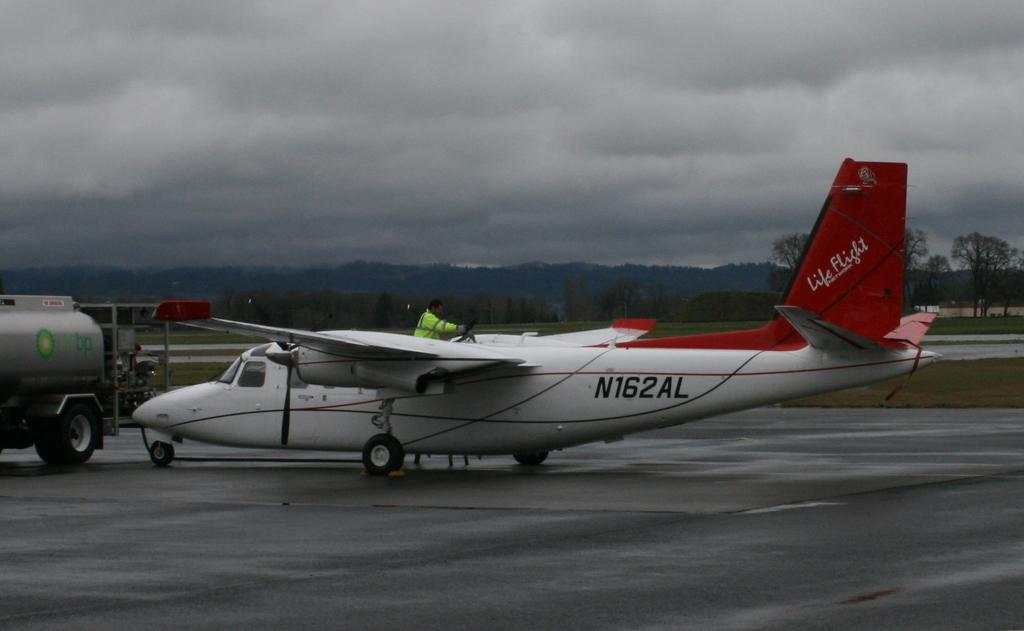<image>
Relay a brief, clear account of the picture shown. A plane sits on a tarmac with the words Life Flight written on the tail. 